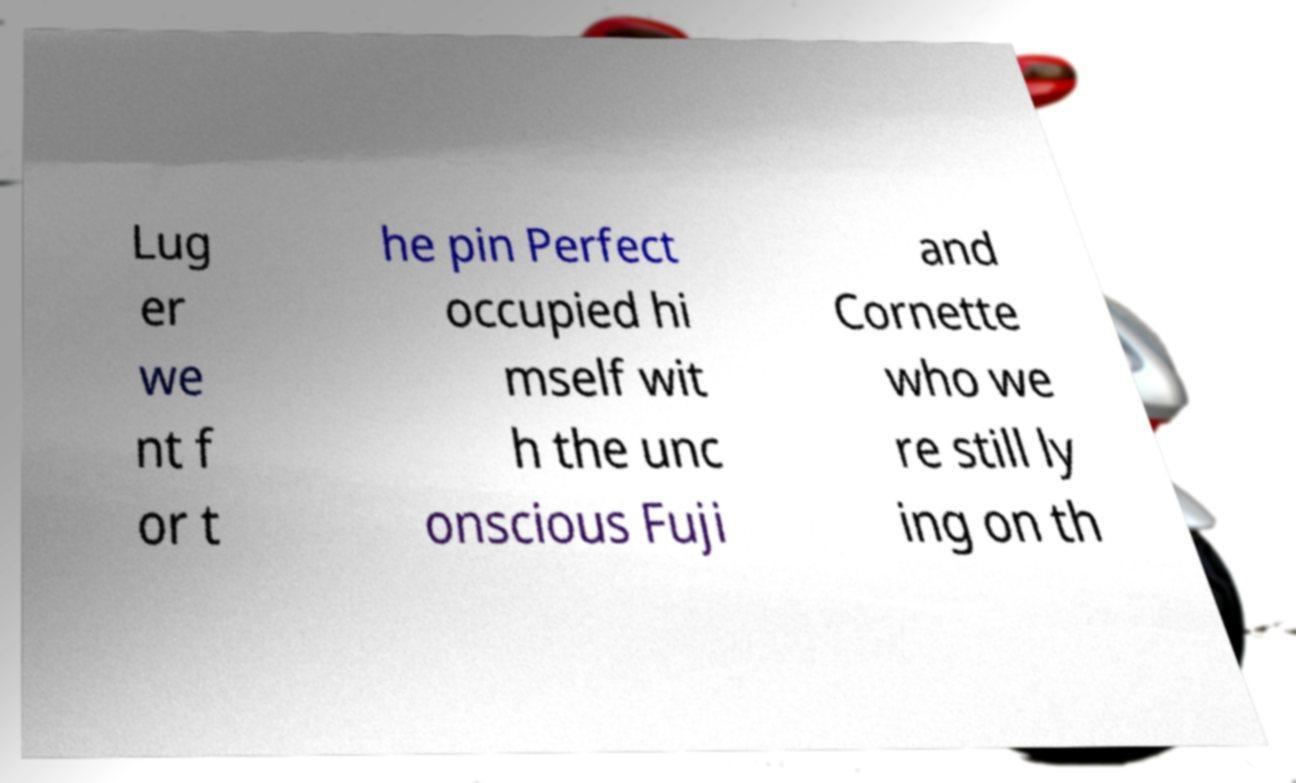What messages or text are displayed in this image? I need them in a readable, typed format. Lug er we nt f or t he pin Perfect occupied hi mself wit h the unc onscious Fuji and Cornette who we re still ly ing on th 